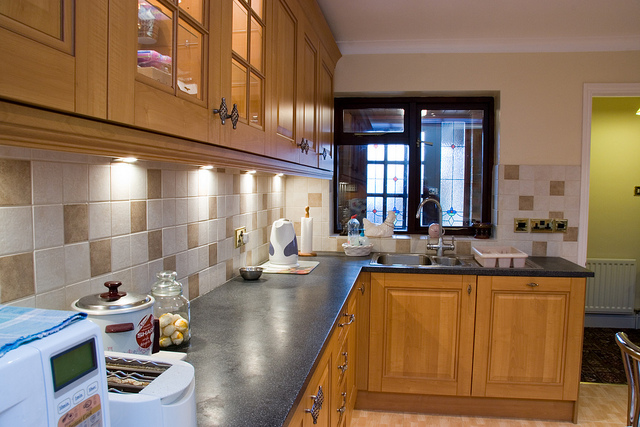What items can you see on the kitchen countertop? On the kitchen countertop, there are several items visible including a kettle, a jar possibly filled with cookies, a bowl with lemons, a roll of paper towels, a cutting board, and various other small kitchen utensils and containers. 